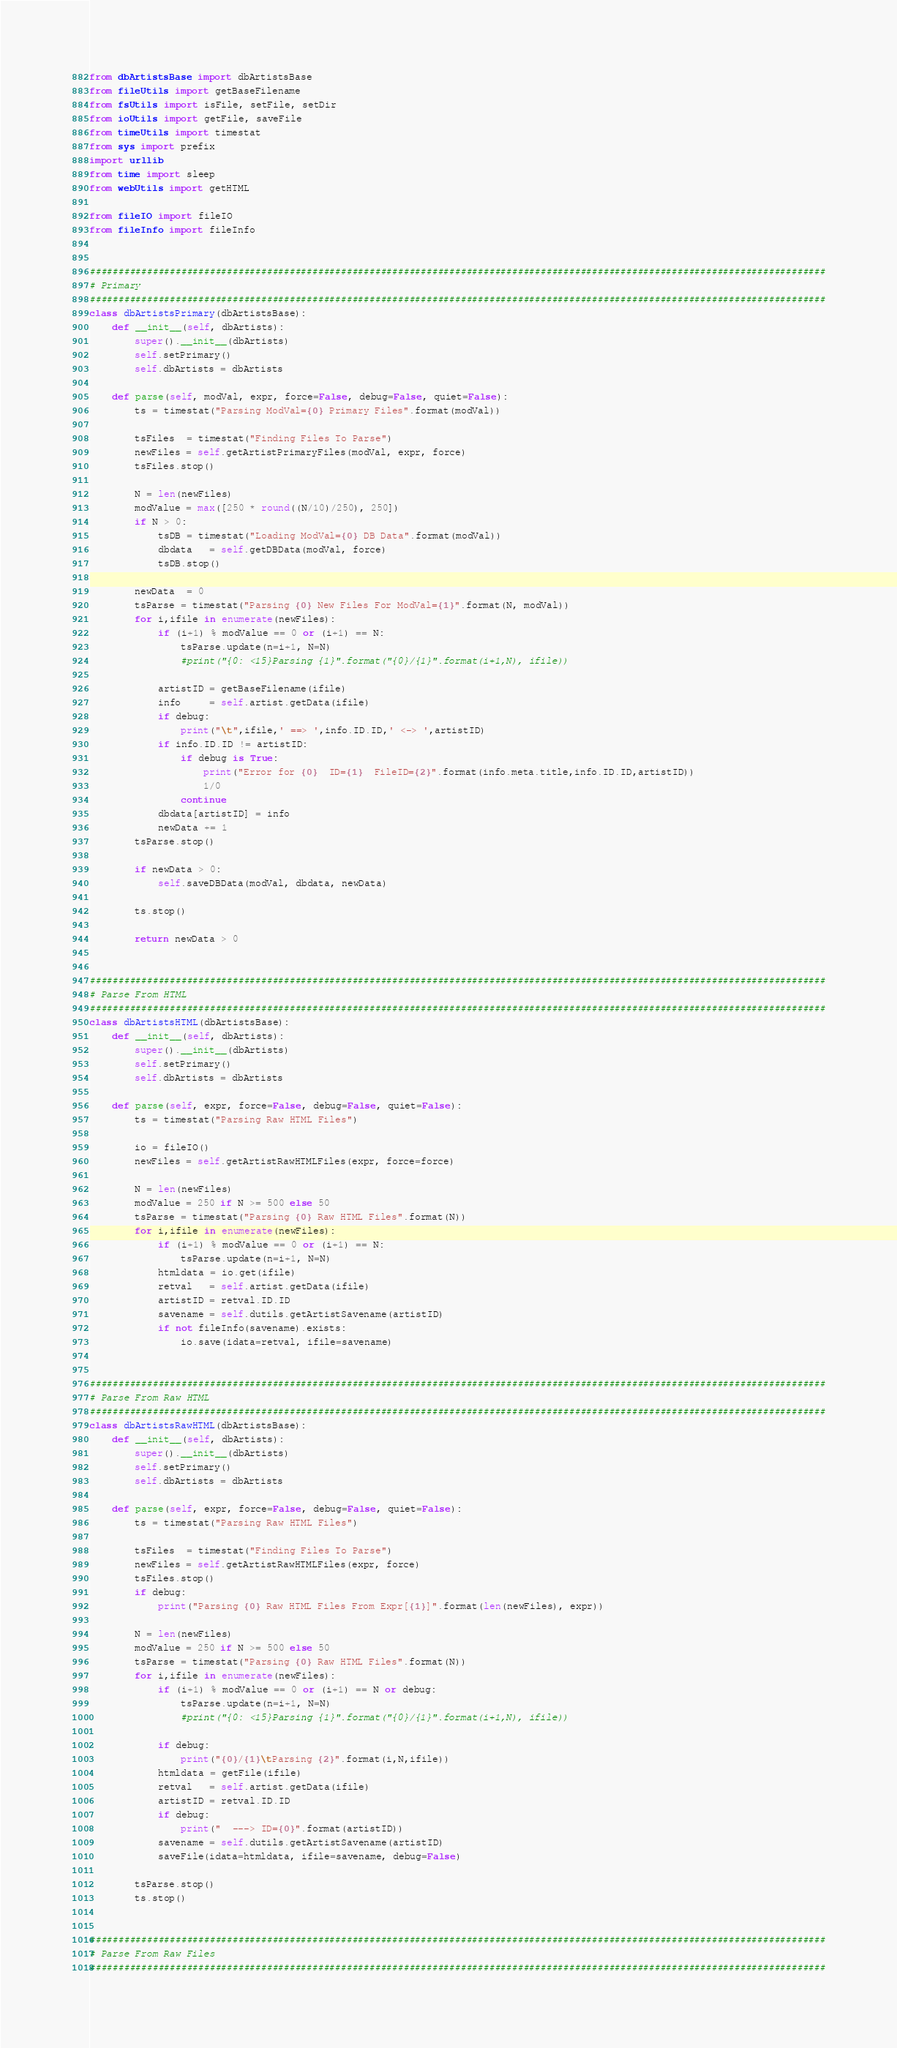Convert code to text. <code><loc_0><loc_0><loc_500><loc_500><_Python_>from dbArtistsBase import dbArtistsBase
from fileUtils import getBaseFilename
from fsUtils import isFile, setFile, setDir
from ioUtils import getFile, saveFile
from timeUtils import timestat
from sys import prefix
import urllib
from time import sleep
from webUtils import getHTML
    
from fileIO import fileIO
from fileInfo import fileInfo


#################################################################################################################################
# Primary
#################################################################################################################################
class dbArtistsPrimary(dbArtistsBase):
    def __init__(self, dbArtists):        
        super().__init__(dbArtists)
        self.setPrimary()
        self.dbArtists = dbArtists
        
    def parse(self, modVal, expr, force=False, debug=False, quiet=False):
        ts = timestat("Parsing ModVal={0} Primary Files".format(modVal))
        
        tsFiles  = timestat("Finding Files To Parse")
        newFiles = self.getArtistPrimaryFiles(modVal, expr, force)
        tsFiles.stop()

        N = len(newFiles)        
        modValue = max([250 * round((N/10)/250), 250])
        if N > 0:
            tsDB = timestat("Loading ModVal={0} DB Data".format(modVal))
            dbdata   = self.getDBData(modVal, force)
            tsDB.stop()
            
        newData  = 0
        tsParse = timestat("Parsing {0} New Files For ModVal={1}".format(N, modVal))
        for i,ifile in enumerate(newFiles):
            if (i+1) % modValue == 0 or (i+1) == N:
                tsParse.update(n=i+1, N=N)
                #print("{0: <15}Parsing {1}".format("{0}/{1}".format(i+1,N), ifile))
                
            artistID = getBaseFilename(ifile)
            info     = self.artist.getData(ifile)
            if debug:
                print("\t",ifile,' ==> ',info.ID.ID,' <-> ',artistID)
            if info.ID.ID != artistID:
                if debug is True:
                    print("Error for {0}  ID={1}  FileID={2}".format(info.meta.title,info.ID.ID,artistID))
                    1/0
                continue
            dbdata[artistID] = info
            newData += 1
        tsParse.stop()
            
        if newData > 0:
            self.saveDBData(modVal, dbdata, newData)
        
        ts.stop()
        
        return newData > 0
    

#################################################################################################################################
# Parse From HTML
#################################################################################################################################
class dbArtistsHTML(dbArtistsBase):
    def __init__(self, dbArtists):
        super().__init__(dbArtists)
        self.setPrimary()
        self.dbArtists = dbArtists
            
    def parse(self, expr, force=False, debug=False, quiet=False):
        ts = timestat("Parsing Raw HTML Files")
        
        io = fileIO()
        newFiles = self.getArtistRawHTMLFiles(expr, force=force)
        
        N = len(newFiles)
        modValue = 250 if N >= 500 else 50
        tsParse = timestat("Parsing {0} Raw HTML Files".format(N))
        for i,ifile in enumerate(newFiles):
            if (i+1) % modValue == 0 or (i+1) == N:
                tsParse.update(n=i+1, N=N)
            htmldata = io.get(ifile)
            retval   = self.artist.getData(ifile)
            artistID = retval.ID.ID
            savename = self.dutils.getArtistSavename(artistID)
            if not fileInfo(savename).exists:
                io.save(idata=retval, ifile=savename)


#################################################################################################################################
# Parse From Raw HTML
#################################################################################################################################
class dbArtistsRawHTML(dbArtistsBase):
    def __init__(self, dbArtists):        
        super().__init__(dbArtists)
        self.setPrimary()
        self.dbArtists = dbArtists
            
    def parse(self, expr, force=False, debug=False, quiet=False):
        ts = timestat("Parsing Raw HTML Files")
        
        tsFiles  = timestat("Finding Files To Parse")
        newFiles = self.getArtistRawHTMLFiles(expr, force)
        tsFiles.stop()
        if debug:
            print("Parsing {0} Raw HTML Files From Expr[{1}]".format(len(newFiles), expr))

        N = len(newFiles)
        modValue = 250 if N >= 500 else 50
        tsParse = timestat("Parsing {0} Raw HTML Files".format(N))
        for i,ifile in enumerate(newFiles):
            if (i+1) % modValue == 0 or (i+1) == N or debug:
                tsParse.update(n=i+1, N=N)
                #print("{0: <15}Parsing {1}".format("{0}/{1}".format(i+1,N), ifile))
            
            if debug:
                print("{0}/{1}\tParsing {2}".format(i,N,ifile))
            htmldata = getFile(ifile)
            retval   = self.artist.getData(ifile)
            artistID = retval.ID.ID
            if debug:
                print("  ---> ID={0}".format(artistID))
            savename = self.dutils.getArtistSavename(artistID)
            saveFile(idata=htmldata, ifile=savename, debug=False)        
        
        tsParse.stop()
        ts.stop()
        
        
#################################################################################################################################
# Parse From Raw Files
#################################################################################################################################</code> 